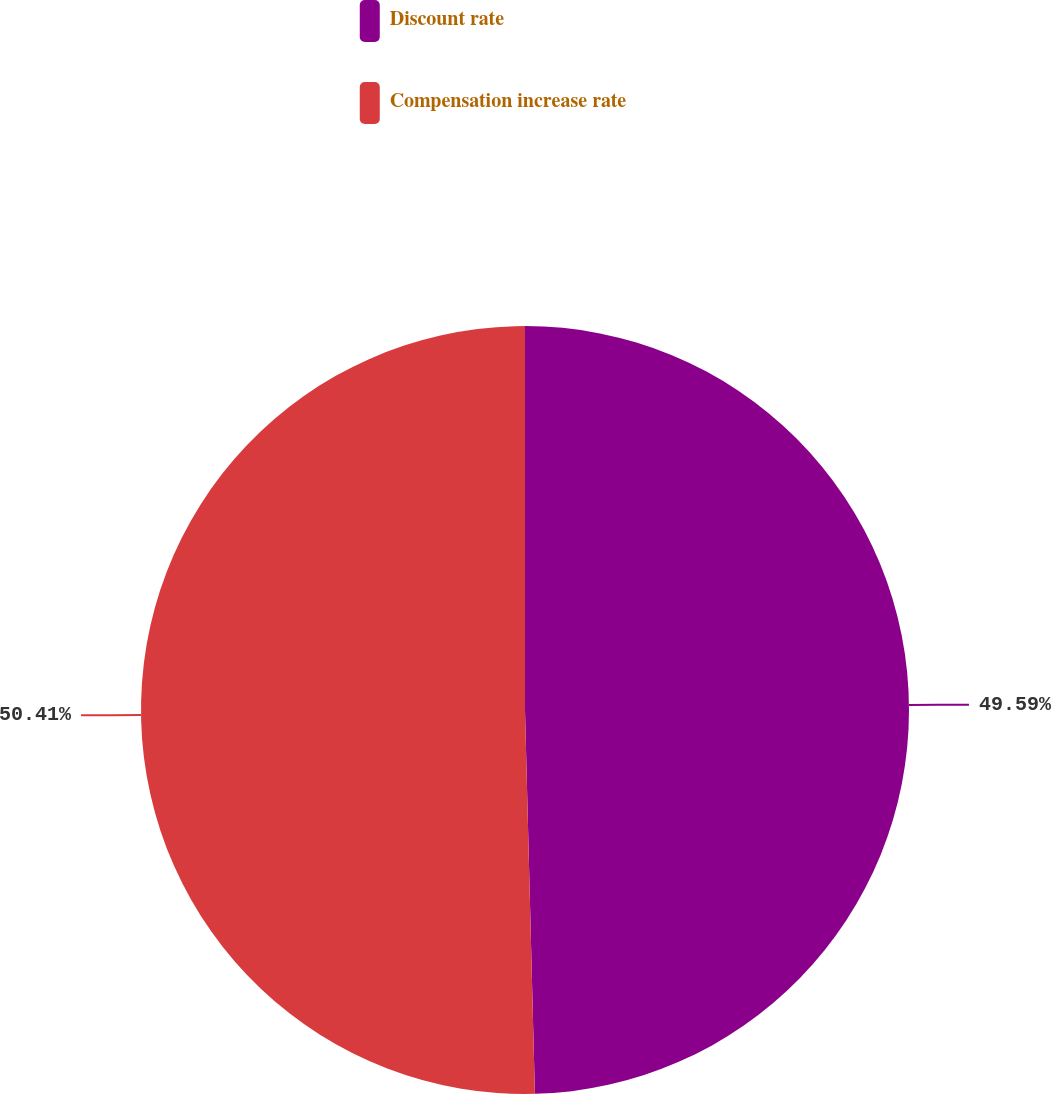Convert chart. <chart><loc_0><loc_0><loc_500><loc_500><pie_chart><fcel>Discount rate<fcel>Compensation increase rate<nl><fcel>49.59%<fcel>50.41%<nl></chart> 